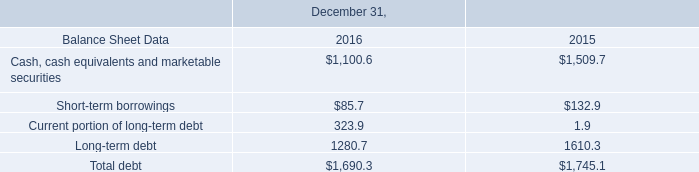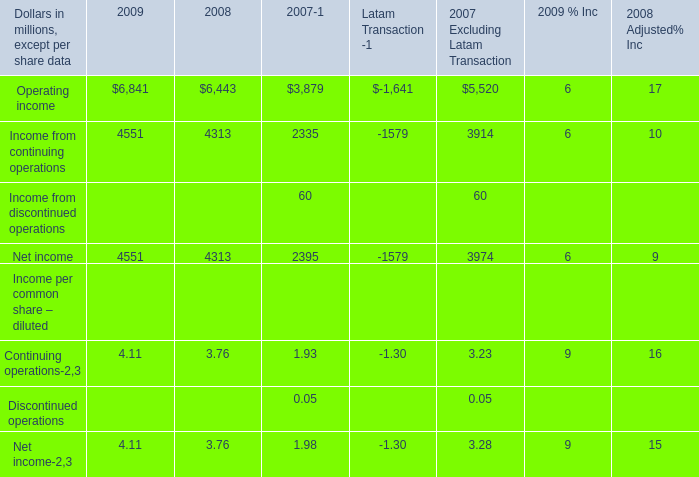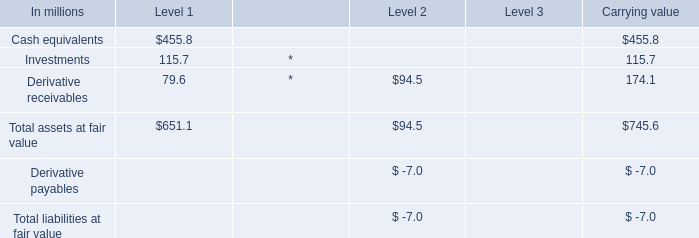what is the average quarterly dividend payment in 2016 , ( in millions ) ? 
Computations: (238.4 / 4)
Answer: 59.6. 